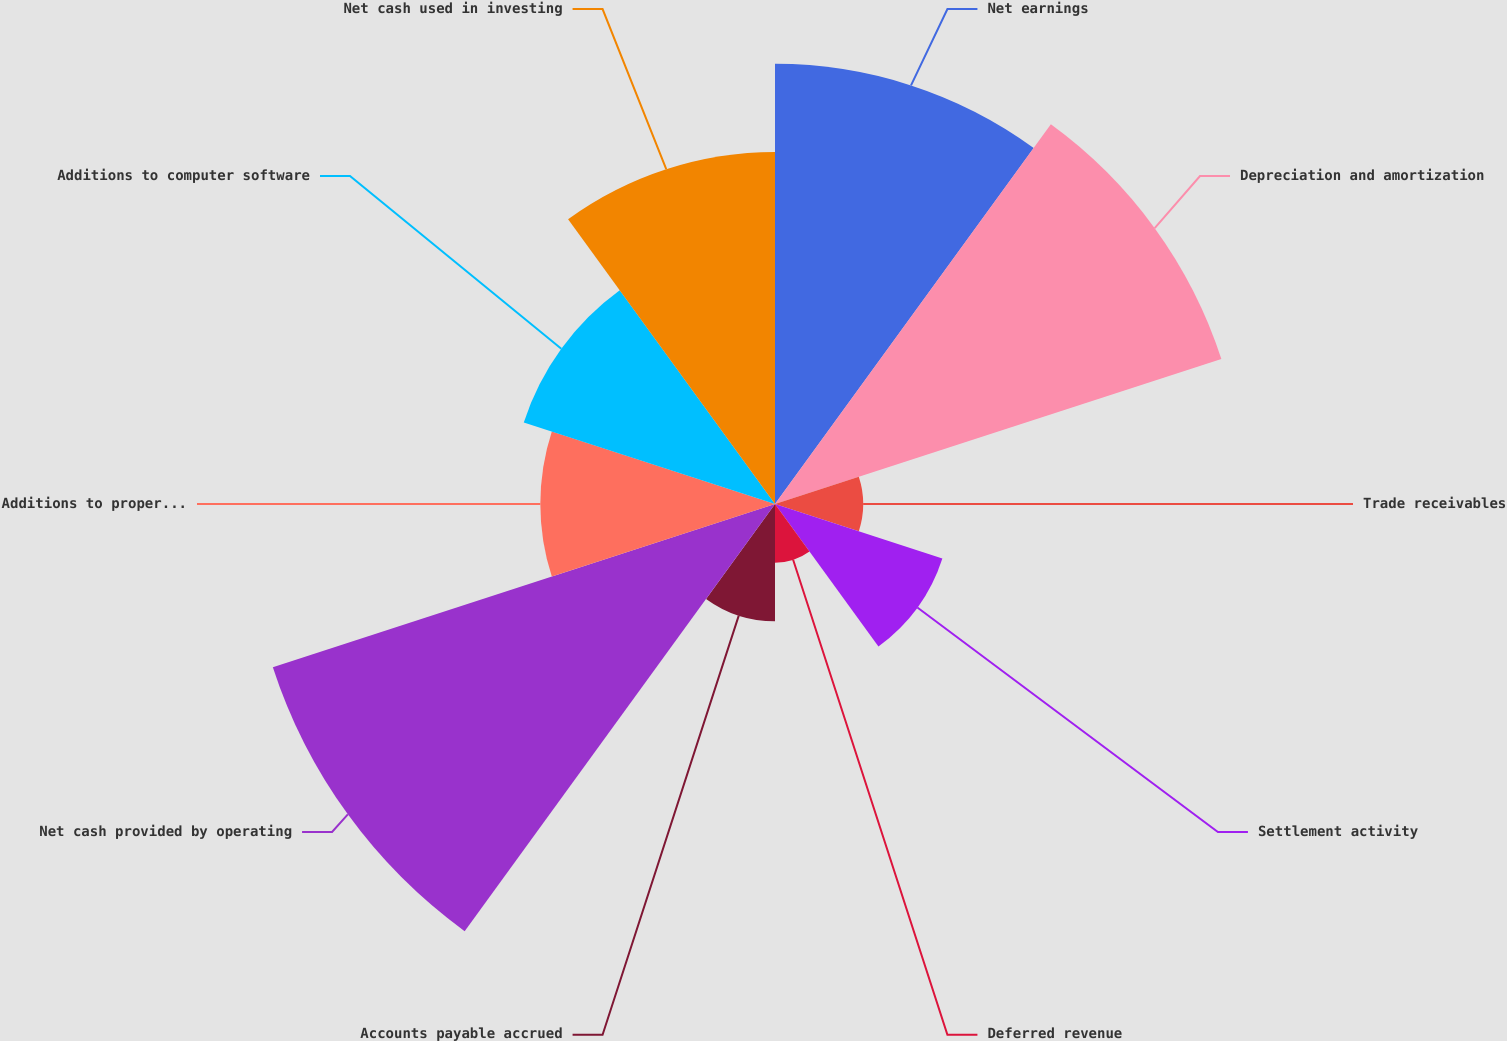Convert chart. <chart><loc_0><loc_0><loc_500><loc_500><pie_chart><fcel>Net earnings<fcel>Depreciation and amortization<fcel>Trade receivables<fcel>Settlement activity<fcel>Deferred revenue<fcel>Accounts payable accrued<fcel>Net cash provided by operating<fcel>Additions to property and<fcel>Additions to computer software<fcel>Net cash used in investing<nl><fcel>16.13%<fcel>17.2%<fcel>3.23%<fcel>6.45%<fcel>2.15%<fcel>4.3%<fcel>19.35%<fcel>8.6%<fcel>9.68%<fcel>12.9%<nl></chart> 